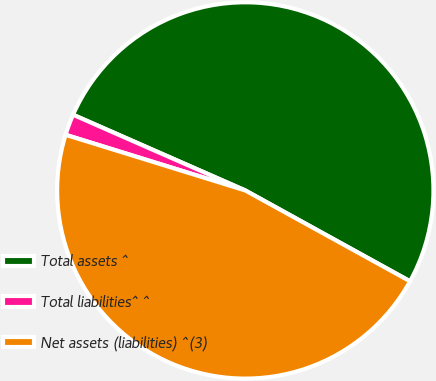Convert chart. <chart><loc_0><loc_0><loc_500><loc_500><pie_chart><fcel>Total assets ^<fcel>Total liabilities^ ^<fcel>Net assets (liabilities) ^(3)<nl><fcel>51.43%<fcel>1.81%<fcel>46.76%<nl></chart> 